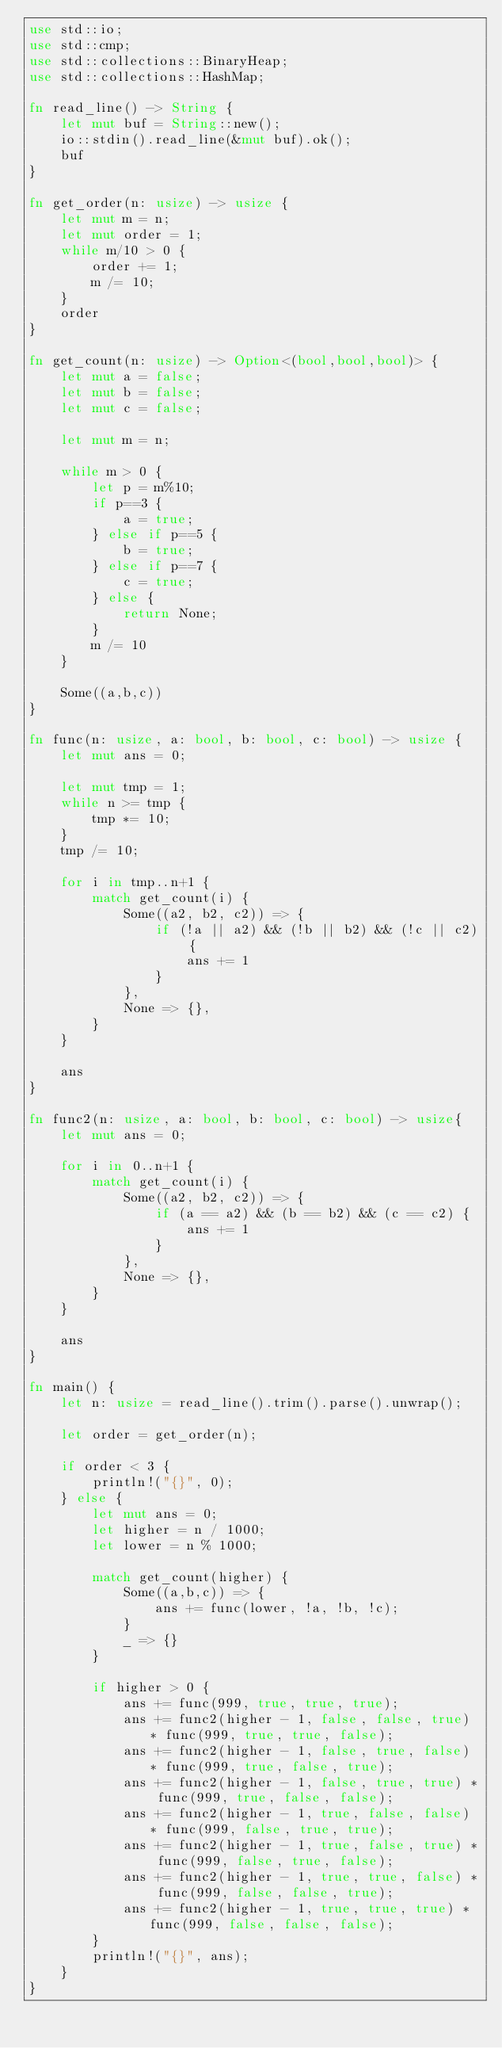<code> <loc_0><loc_0><loc_500><loc_500><_Rust_>use std::io;
use std::cmp;
use std::collections::BinaryHeap;
use std::collections::HashMap;

fn read_line() -> String {
    let mut buf = String::new();
    io::stdin().read_line(&mut buf).ok();
    buf
}

fn get_order(n: usize) -> usize {
    let mut m = n;
    let mut order = 1;
    while m/10 > 0 {
        order += 1;
        m /= 10;
    }
    order
}

fn get_count(n: usize) -> Option<(bool,bool,bool)> {
    let mut a = false;
    let mut b = false;
    let mut c = false;

    let mut m = n;

    while m > 0 {
        let p = m%10;
        if p==3 {
            a = true;
        } else if p==5 {
            b = true;
        } else if p==7 {
            c = true;
        } else {
            return None;
        }
        m /= 10
    }

    Some((a,b,c))
}

fn func(n: usize, a: bool, b: bool, c: bool) -> usize {
    let mut ans = 0;

    let mut tmp = 1;
    while n >= tmp {
        tmp *= 10;
    }
    tmp /= 10;

    for i in tmp..n+1 {
        match get_count(i) {
            Some((a2, b2, c2)) => {
                if (!a || a2) && (!b || b2) && (!c || c2) {
                    ans += 1
                }
            },
            None => {},
        }
    }

    ans
}

fn func2(n: usize, a: bool, b: bool, c: bool) -> usize{
    let mut ans = 0;

    for i in 0..n+1 {
        match get_count(i) {
            Some((a2, b2, c2)) => {
                if (a == a2) && (b == b2) && (c == c2) {
                    ans += 1
                }
            },
            None => {},
        }
    }

    ans
}

fn main() {
    let n: usize = read_line().trim().parse().unwrap();
    
    let order = get_order(n);

    if order < 3 {
        println!("{}", 0);
    } else {
        let mut ans = 0;
        let higher = n / 1000;
        let lower = n % 1000;

        match get_count(higher) {
            Some((a,b,c)) => {
                ans += func(lower, !a, !b, !c);
            }
            _ => {}
        }

        if higher > 0 {
            ans += func(999, true, true, true);
            ans += func2(higher - 1, false, false, true) * func(999, true, true, false);
            ans += func2(higher - 1, false, true, false) * func(999, true, false, true);
            ans += func2(higher - 1, false, true, true) * func(999, true, false, false);
            ans += func2(higher - 1, true, false, false) * func(999, false, true, true);
            ans += func2(higher - 1, true, false, true) * func(999, false, true, false);
            ans += func2(higher - 1, true, true, false) * func(999, false, false, true);
            ans += func2(higher - 1, true, true, true) * func(999, false, false, false);
        }
        println!("{}", ans);
    }
}
</code> 